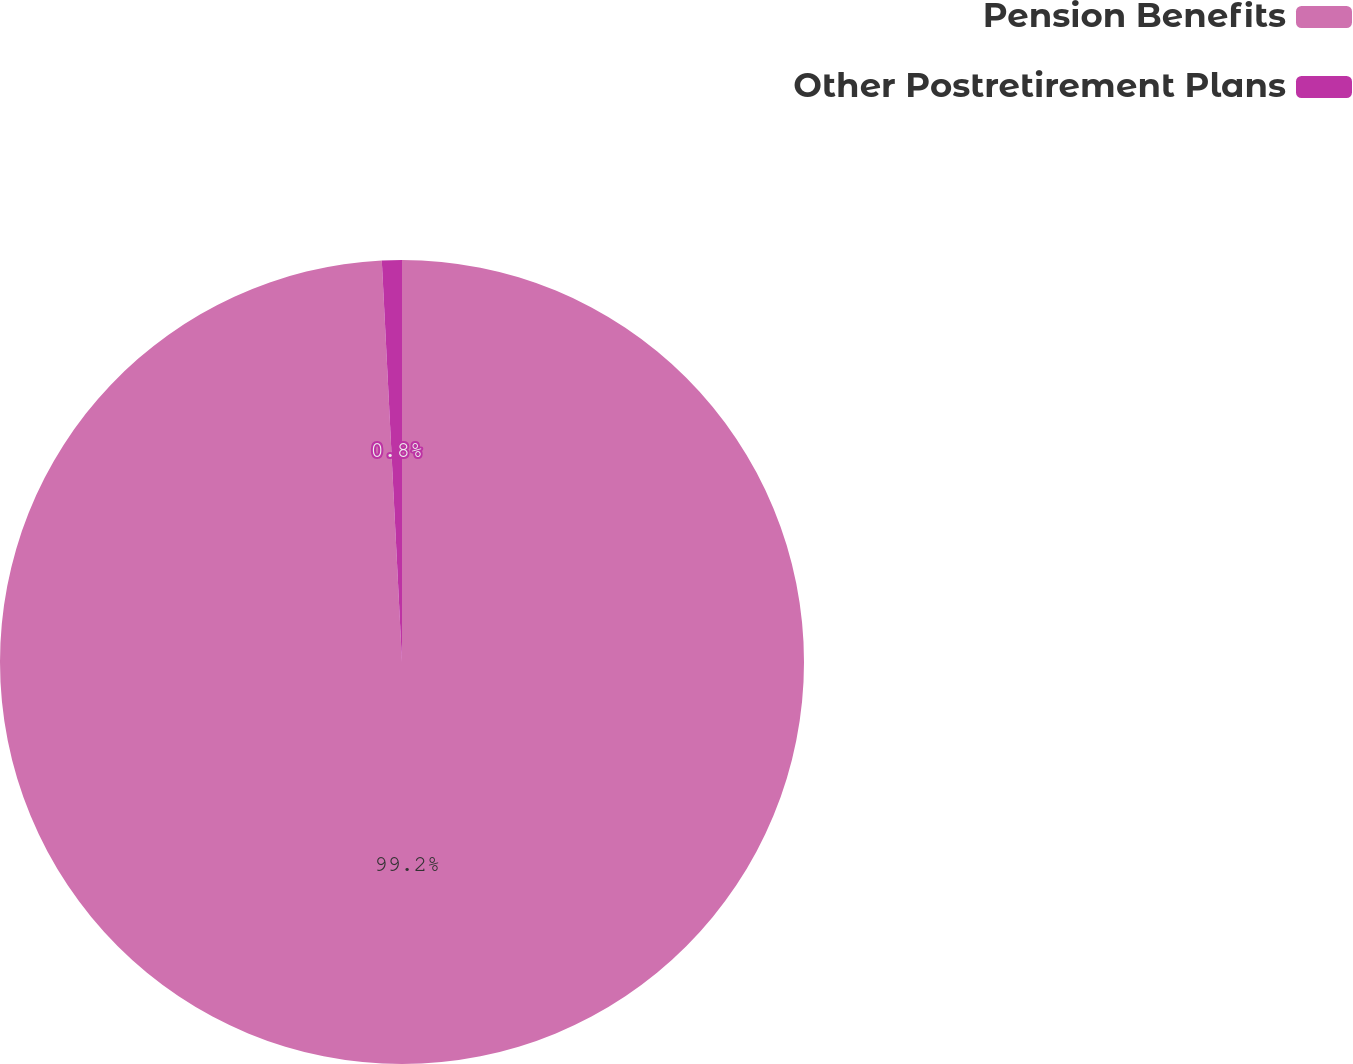<chart> <loc_0><loc_0><loc_500><loc_500><pie_chart><fcel>Pension Benefits<fcel>Other Postretirement Plans<nl><fcel>99.2%<fcel>0.8%<nl></chart> 